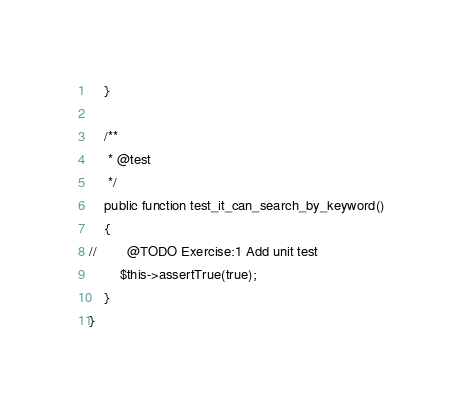<code> <loc_0><loc_0><loc_500><loc_500><_PHP_>    }

    /**
     * @test
     */
    public function test_it_can_search_by_keyword()
    {
//        @TODO Exercise:1 Add unit test
        $this->assertTrue(true);
    }
}
</code> 